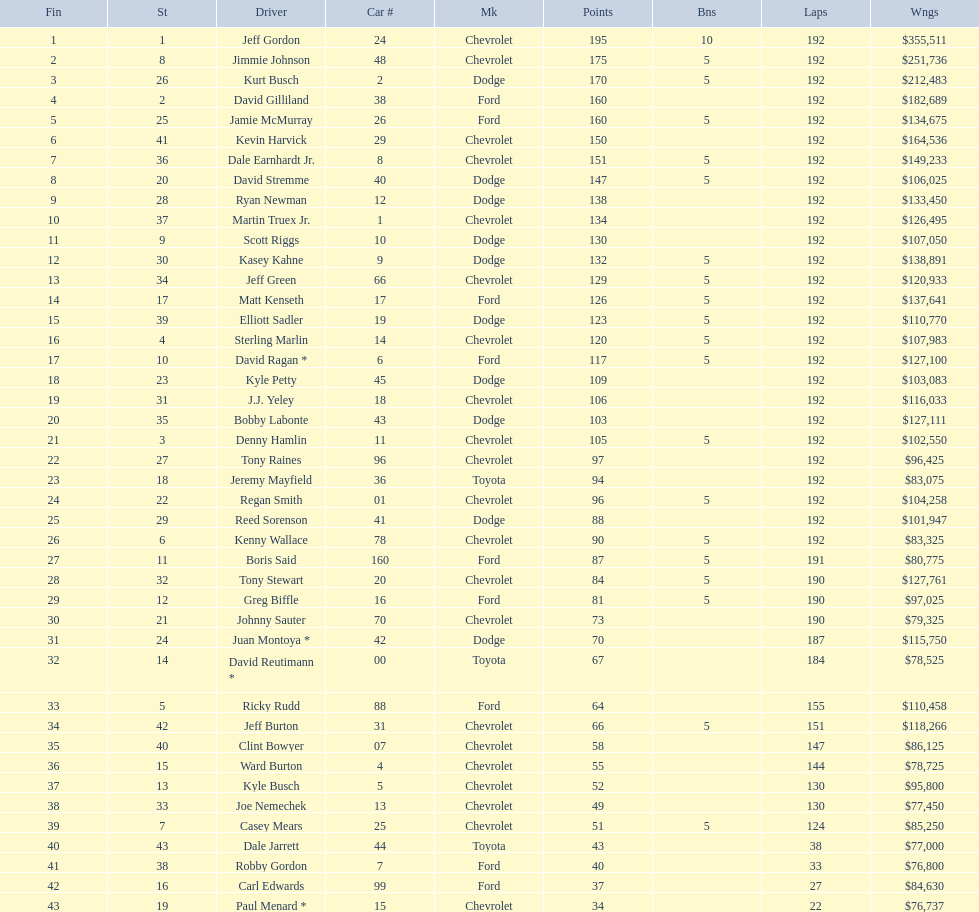How many race car drivers out of the 43 listed drove toyotas? 3. 